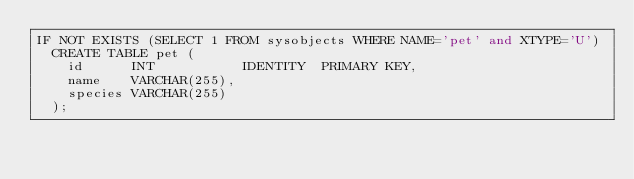<code> <loc_0><loc_0><loc_500><loc_500><_SQL_>IF NOT EXISTS (SELECT 1 FROM sysobjects WHERE NAME='pet' and XTYPE='U')
  CREATE TABLE pet (
    id      INT           IDENTITY  PRIMARY KEY,
    name    VARCHAR(255),
    species VARCHAR(255)
  );
</code> 